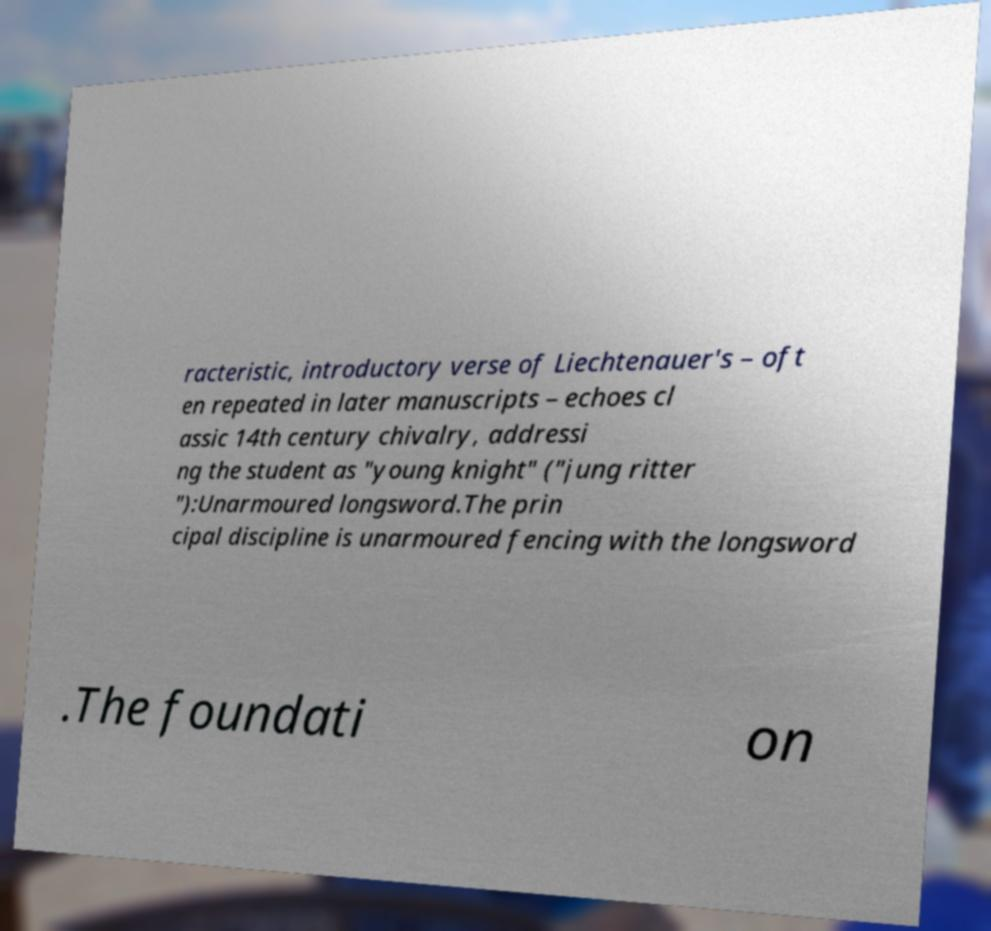There's text embedded in this image that I need extracted. Can you transcribe it verbatim? racteristic, introductory verse of Liechtenauer's – oft en repeated in later manuscripts – echoes cl assic 14th century chivalry, addressi ng the student as "young knight" ("jung ritter "):Unarmoured longsword.The prin cipal discipline is unarmoured fencing with the longsword .The foundati on 